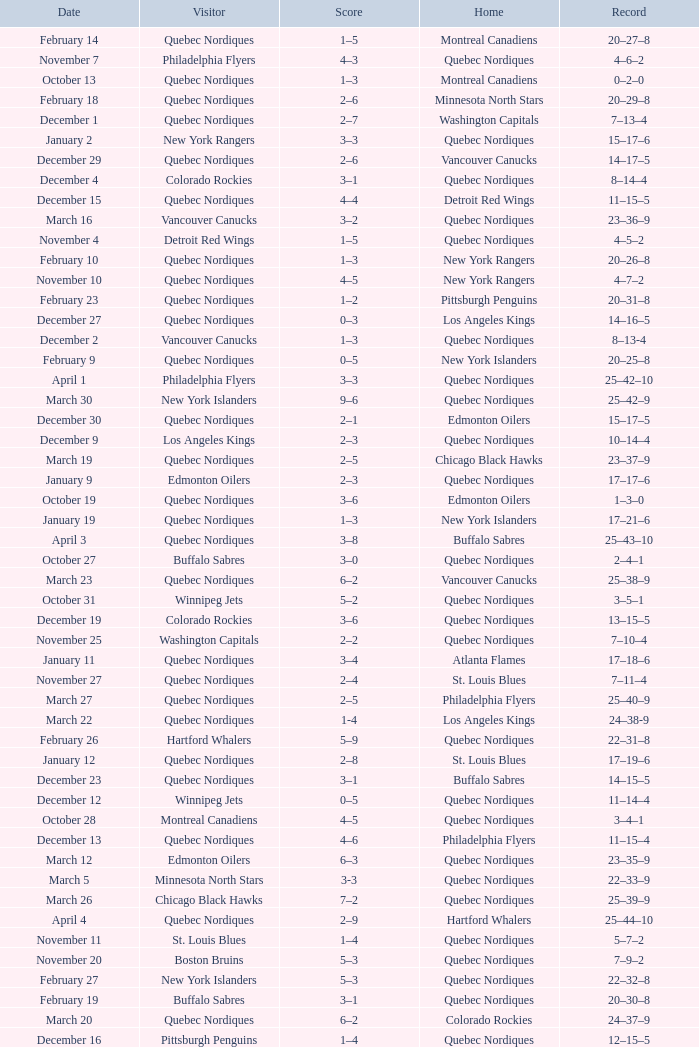Which Home has a Date of april 1? Quebec Nordiques. 